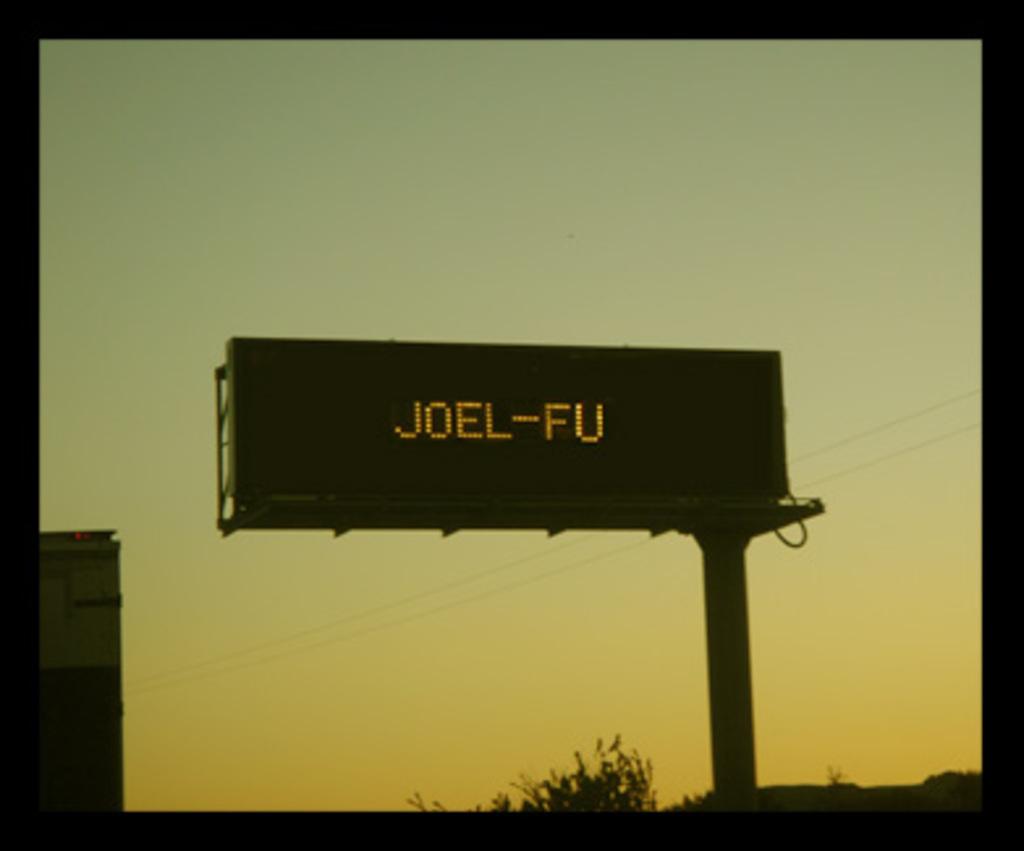What is displayed on the billboard?
Give a very brief answer. Joel-fu. 